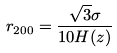Convert formula to latex. <formula><loc_0><loc_0><loc_500><loc_500>r _ { 2 0 0 } = \frac { \sqrt { 3 } \sigma } { 1 0 H ( z ) }</formula> 